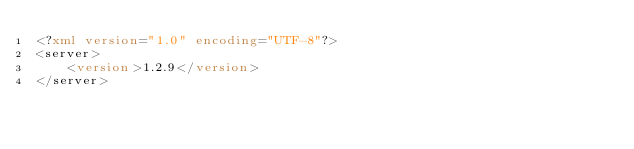Convert code to text. <code><loc_0><loc_0><loc_500><loc_500><_XML_><?xml version="1.0" encoding="UTF-8"?>
<server>
    <version>1.2.9</version>
</server></code> 